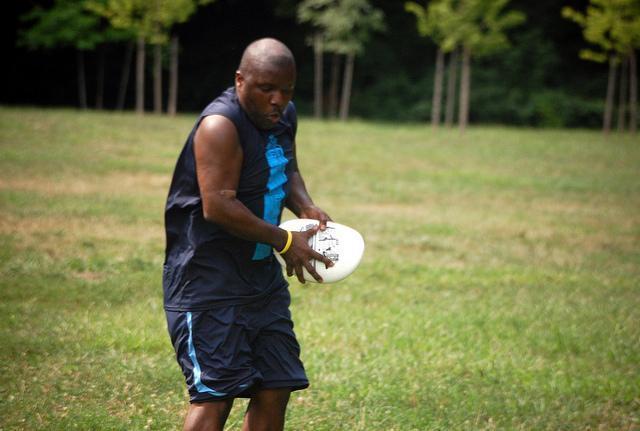How many chairs have a checkered pattern?
Give a very brief answer. 0. 